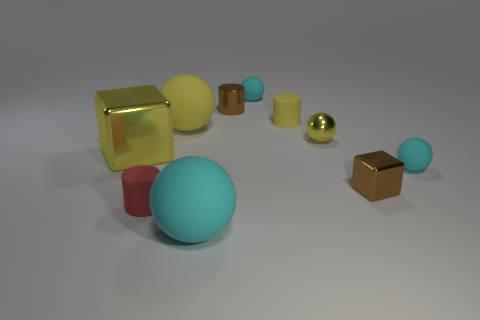The matte object that is both to the left of the large cyan object and behind the tiny red cylinder is what color?
Offer a terse response. Yellow. What number of objects are small red cylinders or matte cylinders in front of the yellow block?
Offer a very short reply. 1. What material is the tiny brown object that is behind the large matte thing that is behind the yellow metal thing that is on the left side of the small brown cylinder?
Give a very brief answer. Metal. Are there any other things that have the same material as the brown block?
Provide a succinct answer. Yes. Is the color of the big rubber ball behind the yellow metallic cube the same as the big shiny block?
Your response must be concise. Yes. What number of red objects are either tiny matte things or tiny metal spheres?
Make the answer very short. 1. How many other objects are there of the same shape as the small red matte thing?
Provide a succinct answer. 2. Are the tiny yellow sphere and the tiny yellow cylinder made of the same material?
Your answer should be very brief. No. There is a large thing that is both to the right of the tiny red cylinder and in front of the small yellow ball; what is it made of?
Provide a short and direct response. Rubber. The small matte ball that is left of the tiny block is what color?
Provide a succinct answer. Cyan. 